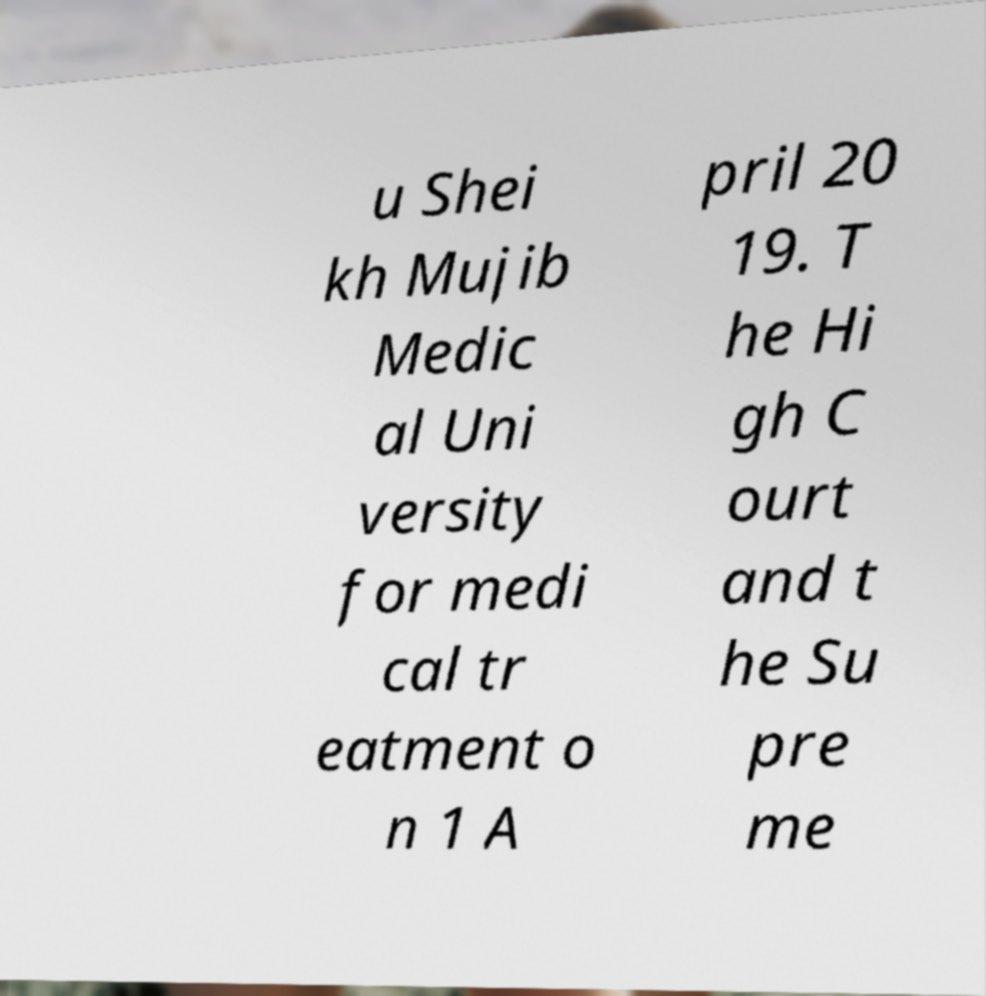Can you read and provide the text displayed in the image?This photo seems to have some interesting text. Can you extract and type it out for me? u Shei kh Mujib Medic al Uni versity for medi cal tr eatment o n 1 A pril 20 19. T he Hi gh C ourt and t he Su pre me 